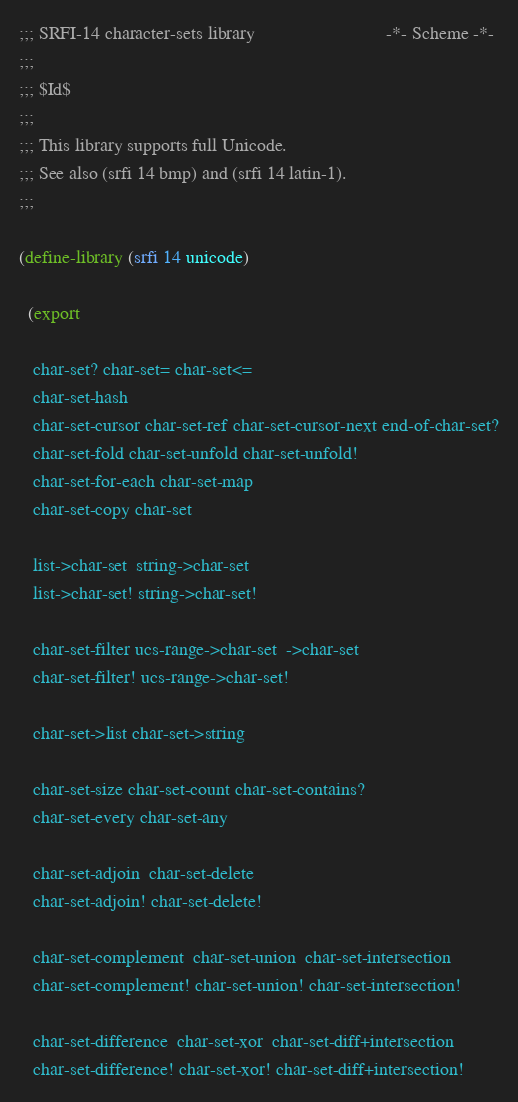<code> <loc_0><loc_0><loc_500><loc_500><_Scheme_>;;; SRFI-14 character-sets library                            -*- Scheme -*-
;;;
;;; $Id$
;;;
;;; This library supports full Unicode.
;;; See also (srfi 14 bmp) and (srfi 14 latin-1).
;;;

(define-library (srfi 14 unicode)

  (export

   char-set? char-set= char-set<=
   char-set-hash 
   char-set-cursor char-set-ref char-set-cursor-next end-of-char-set?
   char-set-fold char-set-unfold char-set-unfold!
   char-set-for-each char-set-map
   char-set-copy char-set

   list->char-set  string->char-set 
   list->char-set! string->char-set! 

   char-set-filter ucs-range->char-set  ->char-set
   char-set-filter! ucs-range->char-set!

   char-set->list char-set->string

   char-set-size char-set-count char-set-contains?
   char-set-every char-set-any

   char-set-adjoin  char-set-delete 
   char-set-adjoin! char-set-delete!

   char-set-complement  char-set-union  char-set-intersection  
   char-set-complement! char-set-union! char-set-intersection! 

   char-set-difference  char-set-xor  char-set-diff+intersection
   char-set-difference! char-set-xor! char-set-diff+intersection!
</code> 